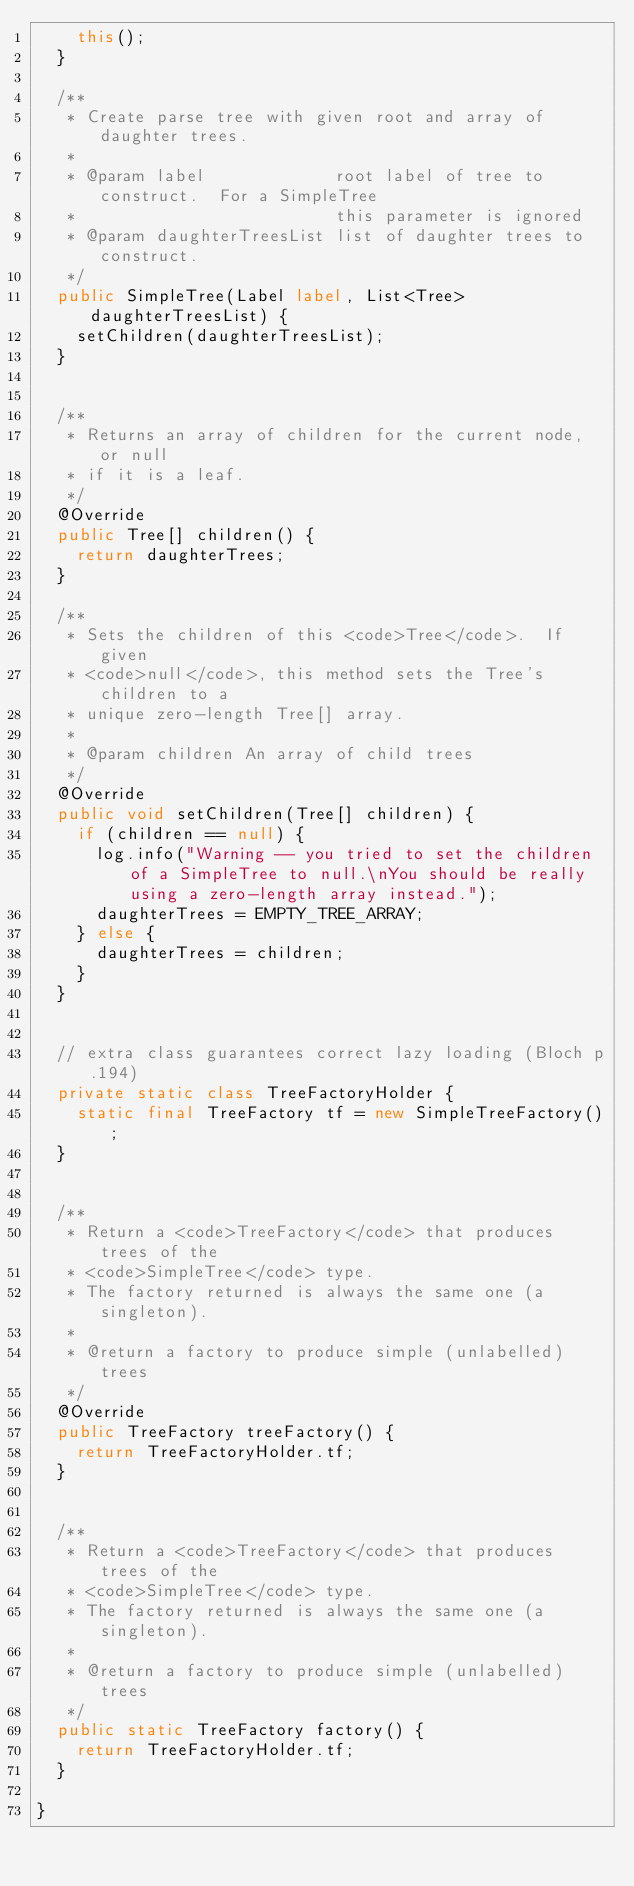Convert code to text. <code><loc_0><loc_0><loc_500><loc_500><_Java_>    this();
  }

  /**
   * Create parse tree with given root and array of daughter trees.
   *
   * @param label             root label of tree to construct.  For a SimpleTree
   *                          this parameter is ignored
   * @param daughterTreesList list of daughter trees to construct.
   */
  public SimpleTree(Label label, List<Tree> daughterTreesList) {
    setChildren(daughterTreesList);
  }


  /**
   * Returns an array of children for the current node, or null
   * if it is a leaf.
   */
  @Override
  public Tree[] children() {
    return daughterTrees;
  }

  /**
   * Sets the children of this <code>Tree</code>.  If given
   * <code>null</code>, this method sets the Tree's children to a
   * unique zero-length Tree[] array.
   *
   * @param children An array of child trees
   */
  @Override
  public void setChildren(Tree[] children) {
    if (children == null) {
      log.info("Warning -- you tried to set the children of a SimpleTree to null.\nYou should be really using a zero-length array instead.");
      daughterTrees = EMPTY_TREE_ARRAY;
    } else {
      daughterTrees = children;
    }
  }


  // extra class guarantees correct lazy loading (Bloch p.194)
  private static class TreeFactoryHolder {
    static final TreeFactory tf = new SimpleTreeFactory();
  }


  /**
   * Return a <code>TreeFactory</code> that produces trees of the
   * <code>SimpleTree</code> type.
   * The factory returned is always the same one (a singleton).
   *
   * @return a factory to produce simple (unlabelled) trees
   */
  @Override
  public TreeFactory treeFactory() {
    return TreeFactoryHolder.tf;
  }


  /**
   * Return a <code>TreeFactory</code> that produces trees of the
   * <code>SimpleTree</code> type.
   * The factory returned is always the same one (a singleton).
   *
   * @return a factory to produce simple (unlabelled) trees
   */
  public static TreeFactory factory() {
    return TreeFactoryHolder.tf;
  }

}
</code> 